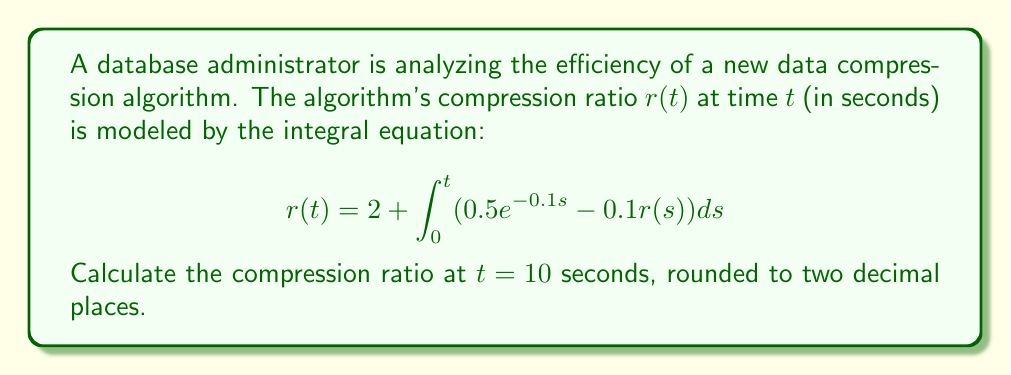What is the answer to this math problem? To solve this integral equation, we'll use the Picard iteration method:

1) Start with an initial guess: $r_0(t) = 2$ (the constant term)

2) Iterate using the formula:
   $$r_{n+1}(t) = 2 + \int_0^t (0.5e^{-0.1s} - 0.1r_n(s))ds$$

3) First iteration:
   $$r_1(t) = 2 + \int_0^t (0.5e^{-0.1s} - 0.1 \cdot 2)ds$$
   $$= 2 + [-5e^{-0.1s} - 0.2s]_0^t$$
   $$= 2 + (-5e^{-0.1t} + 5 - 0.2t)$$
   $$= 7 - 5e^{-0.1t} - 0.2t$$

4) Second iteration:
   $$r_2(t) = 2 + \int_0^t (0.5e^{-0.1s} - 0.1(7 - 5e^{-0.1s} - 0.2s))ds$$
   $$= 2 + [(-5e^{-0.1s}) - 0.7s + 0.5e^{-0.1s} + 0.01s^2]_0^t$$
   $$= 2 + (-4.5e^{-0.1t} + 4.5 - 0.7t + 0.01t^2)$$
   $$= 6.5 - 4.5e^{-0.1t} - 0.7t + 0.01t^2$$

5) The solution converges quickly, so we'll use $r_2(t)$ as our approximation.

6) Evaluate at $t = 10$:
   $$r_2(10) = 6.5 - 4.5e^{-1} - 0.7(10) + 0.01(10)^2$$
   $$= 6.5 - 4.5(0.3679) - 7 + 1$$
   $$= 6.5 - 1.6556 - 7 + 1$$
   $$= -1.1556$$

7) Round to two decimal places: -1.16
Answer: -1.16 